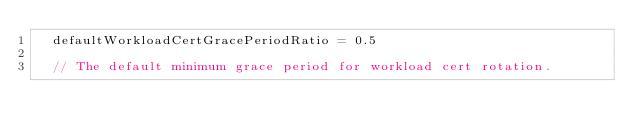<code> <loc_0><loc_0><loc_500><loc_500><_Go_>	defaultWorkloadCertGracePeriodRatio = 0.5

	// The default minimum grace period for workload cert rotation.</code> 